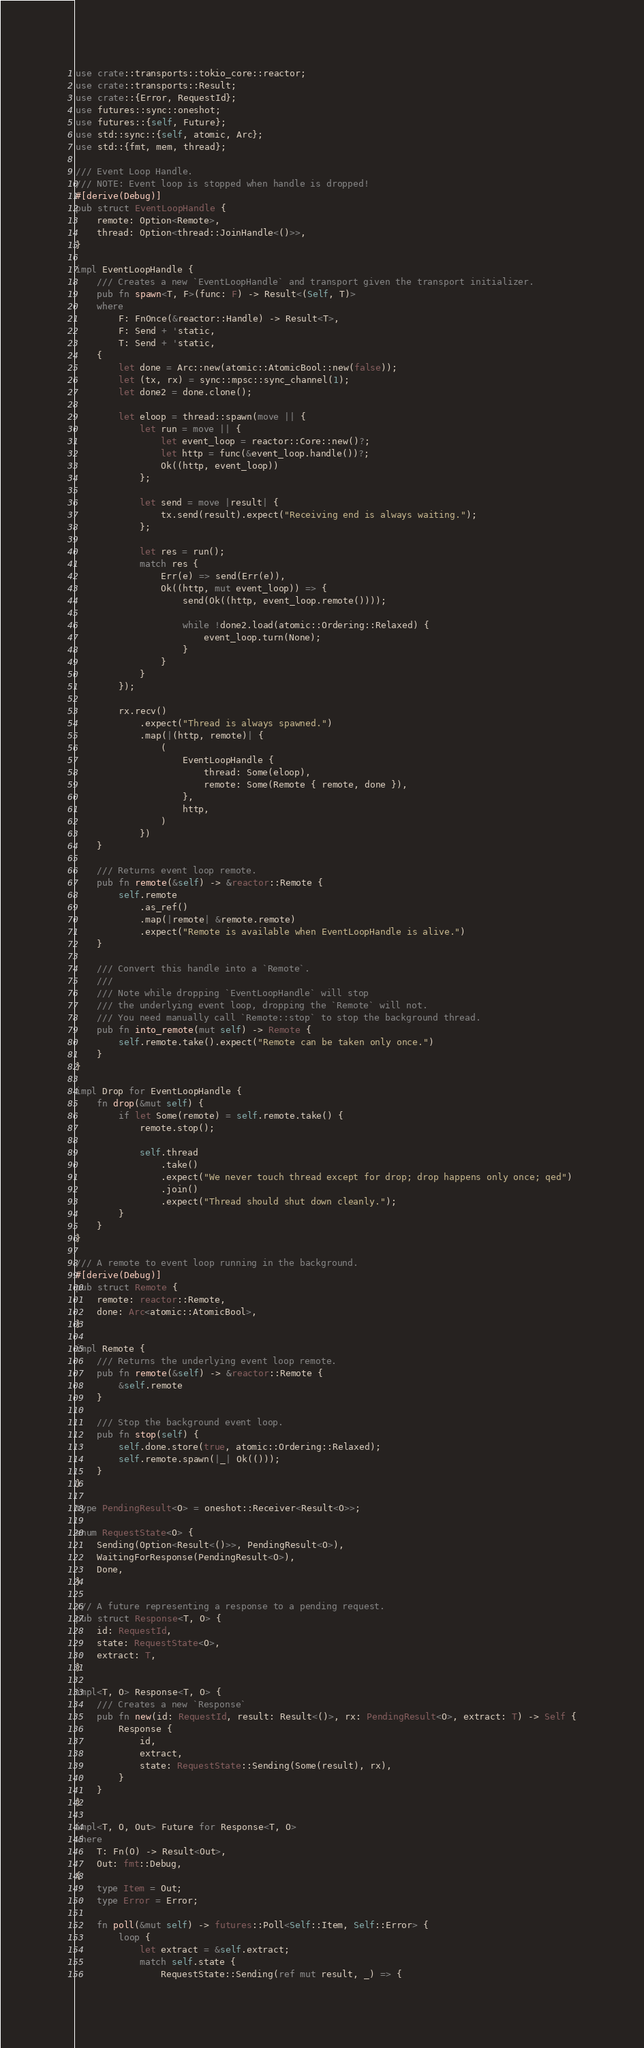Convert code to text. <code><loc_0><loc_0><loc_500><loc_500><_Rust_>use crate::transports::tokio_core::reactor;
use crate::transports::Result;
use crate::{Error, RequestId};
use futures::sync::oneshot;
use futures::{self, Future};
use std::sync::{self, atomic, Arc};
use std::{fmt, mem, thread};

/// Event Loop Handle.
/// NOTE: Event loop is stopped when handle is dropped!
#[derive(Debug)]
pub struct EventLoopHandle {
    remote: Option<Remote>,
    thread: Option<thread::JoinHandle<()>>,
}

impl EventLoopHandle {
    /// Creates a new `EventLoopHandle` and transport given the transport initializer.
    pub fn spawn<T, F>(func: F) -> Result<(Self, T)>
    where
        F: FnOnce(&reactor::Handle) -> Result<T>,
        F: Send + 'static,
        T: Send + 'static,
    {
        let done = Arc::new(atomic::AtomicBool::new(false));
        let (tx, rx) = sync::mpsc::sync_channel(1);
        let done2 = done.clone();

        let eloop = thread::spawn(move || {
            let run = move || {
                let event_loop = reactor::Core::new()?;
                let http = func(&event_loop.handle())?;
                Ok((http, event_loop))
            };

            let send = move |result| {
                tx.send(result).expect("Receiving end is always waiting.");
            };

            let res = run();
            match res {
                Err(e) => send(Err(e)),
                Ok((http, mut event_loop)) => {
                    send(Ok((http, event_loop.remote())));

                    while !done2.load(atomic::Ordering::Relaxed) {
                        event_loop.turn(None);
                    }
                }
            }
        });

        rx.recv()
            .expect("Thread is always spawned.")
            .map(|(http, remote)| {
                (
                    EventLoopHandle {
                        thread: Some(eloop),
                        remote: Some(Remote { remote, done }),
                    },
                    http,
                )
            })
    }

    /// Returns event loop remote.
    pub fn remote(&self) -> &reactor::Remote {
        self.remote
            .as_ref()
            .map(|remote| &remote.remote)
            .expect("Remote is available when EventLoopHandle is alive.")
    }

    /// Convert this handle into a `Remote`.
    ///
    /// Note while dropping `EventLoopHandle` will stop
    /// the underlying event loop, dropping the `Remote` will not.
    /// You need manually call `Remote::stop` to stop the background thread.
    pub fn into_remote(mut self) -> Remote {
        self.remote.take().expect("Remote can be taken only once.")
    }
}

impl Drop for EventLoopHandle {
    fn drop(&mut self) {
        if let Some(remote) = self.remote.take() {
            remote.stop();

            self.thread
                .take()
                .expect("We never touch thread except for drop; drop happens only once; qed")
                .join()
                .expect("Thread should shut down cleanly.");
        }
    }
}

/// A remote to event loop running in the background.
#[derive(Debug)]
pub struct Remote {
    remote: reactor::Remote,
    done: Arc<atomic::AtomicBool>,
}

impl Remote {
    /// Returns the underlying event loop remote.
    pub fn remote(&self) -> &reactor::Remote {
        &self.remote
    }

    /// Stop the background event loop.
    pub fn stop(self) {
        self.done.store(true, atomic::Ordering::Relaxed);
        self.remote.spawn(|_| Ok(()));
    }
}

type PendingResult<O> = oneshot::Receiver<Result<O>>;

enum RequestState<O> {
    Sending(Option<Result<()>>, PendingResult<O>),
    WaitingForResponse(PendingResult<O>),
    Done,
}

/// A future representing a response to a pending request.
pub struct Response<T, O> {
    id: RequestId,
    state: RequestState<O>,
    extract: T,
}

impl<T, O> Response<T, O> {
    /// Creates a new `Response`
    pub fn new(id: RequestId, result: Result<()>, rx: PendingResult<O>, extract: T) -> Self {
        Response {
            id,
            extract,
            state: RequestState::Sending(Some(result), rx),
        }
    }
}

impl<T, O, Out> Future for Response<T, O>
where
    T: Fn(O) -> Result<Out>,
    Out: fmt::Debug,
{
    type Item = Out;
    type Error = Error;

    fn poll(&mut self) -> futures::Poll<Self::Item, Self::Error> {
        loop {
            let extract = &self.extract;
            match self.state {
                RequestState::Sending(ref mut result, _) => {</code> 